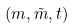<formula> <loc_0><loc_0><loc_500><loc_500>( m , \tilde { m } , t )</formula> 